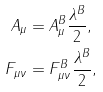Convert formula to latex. <formula><loc_0><loc_0><loc_500><loc_500>A _ { \mu } & = A _ { \mu } ^ { B } \frac { \lambda ^ { B } } { 2 } , \\ F _ { \mu \nu } & = F _ { \mu \nu } ^ { B } \frac { \lambda ^ { B } } { 2 } ,</formula> 